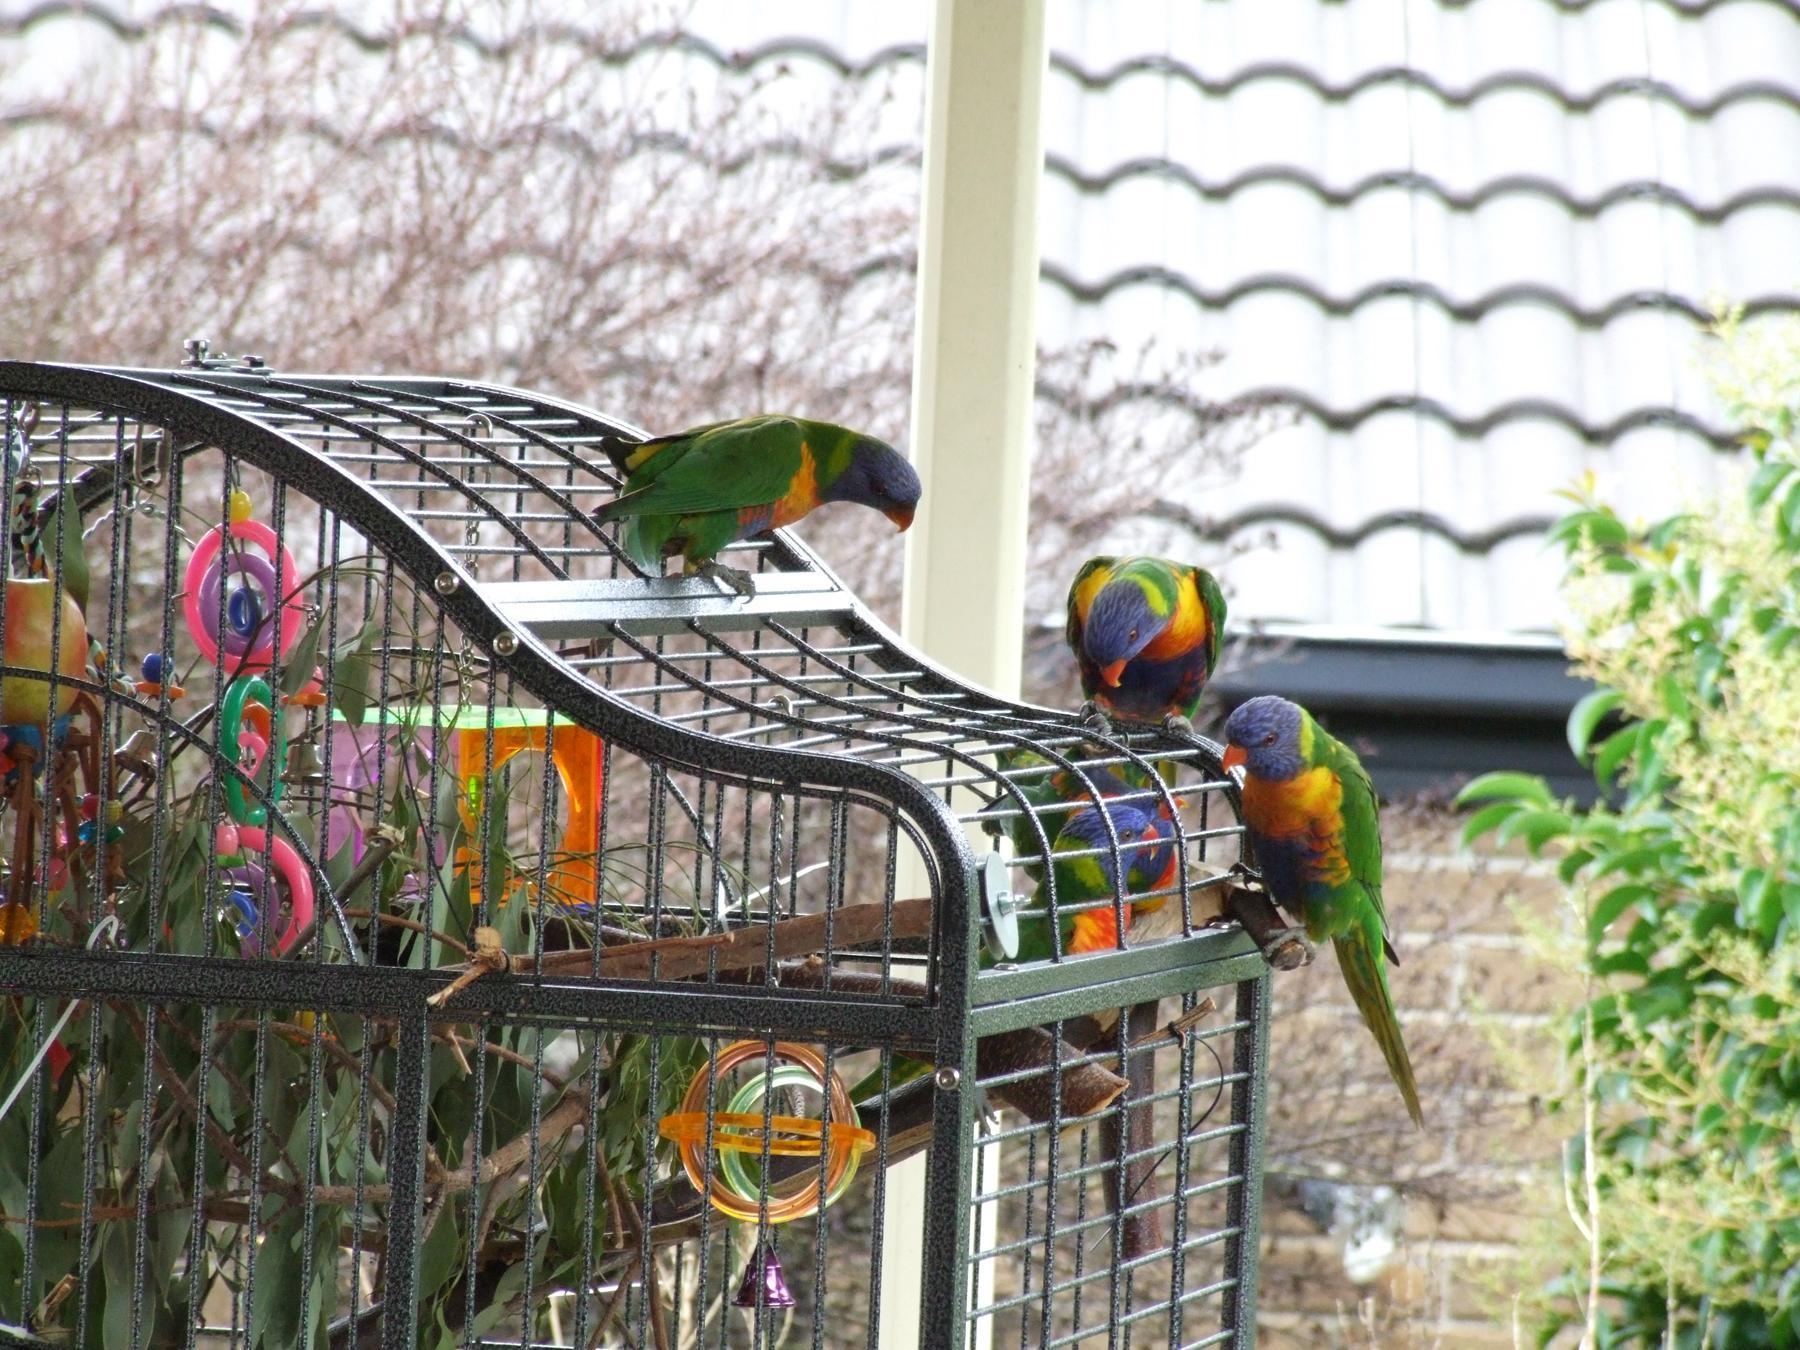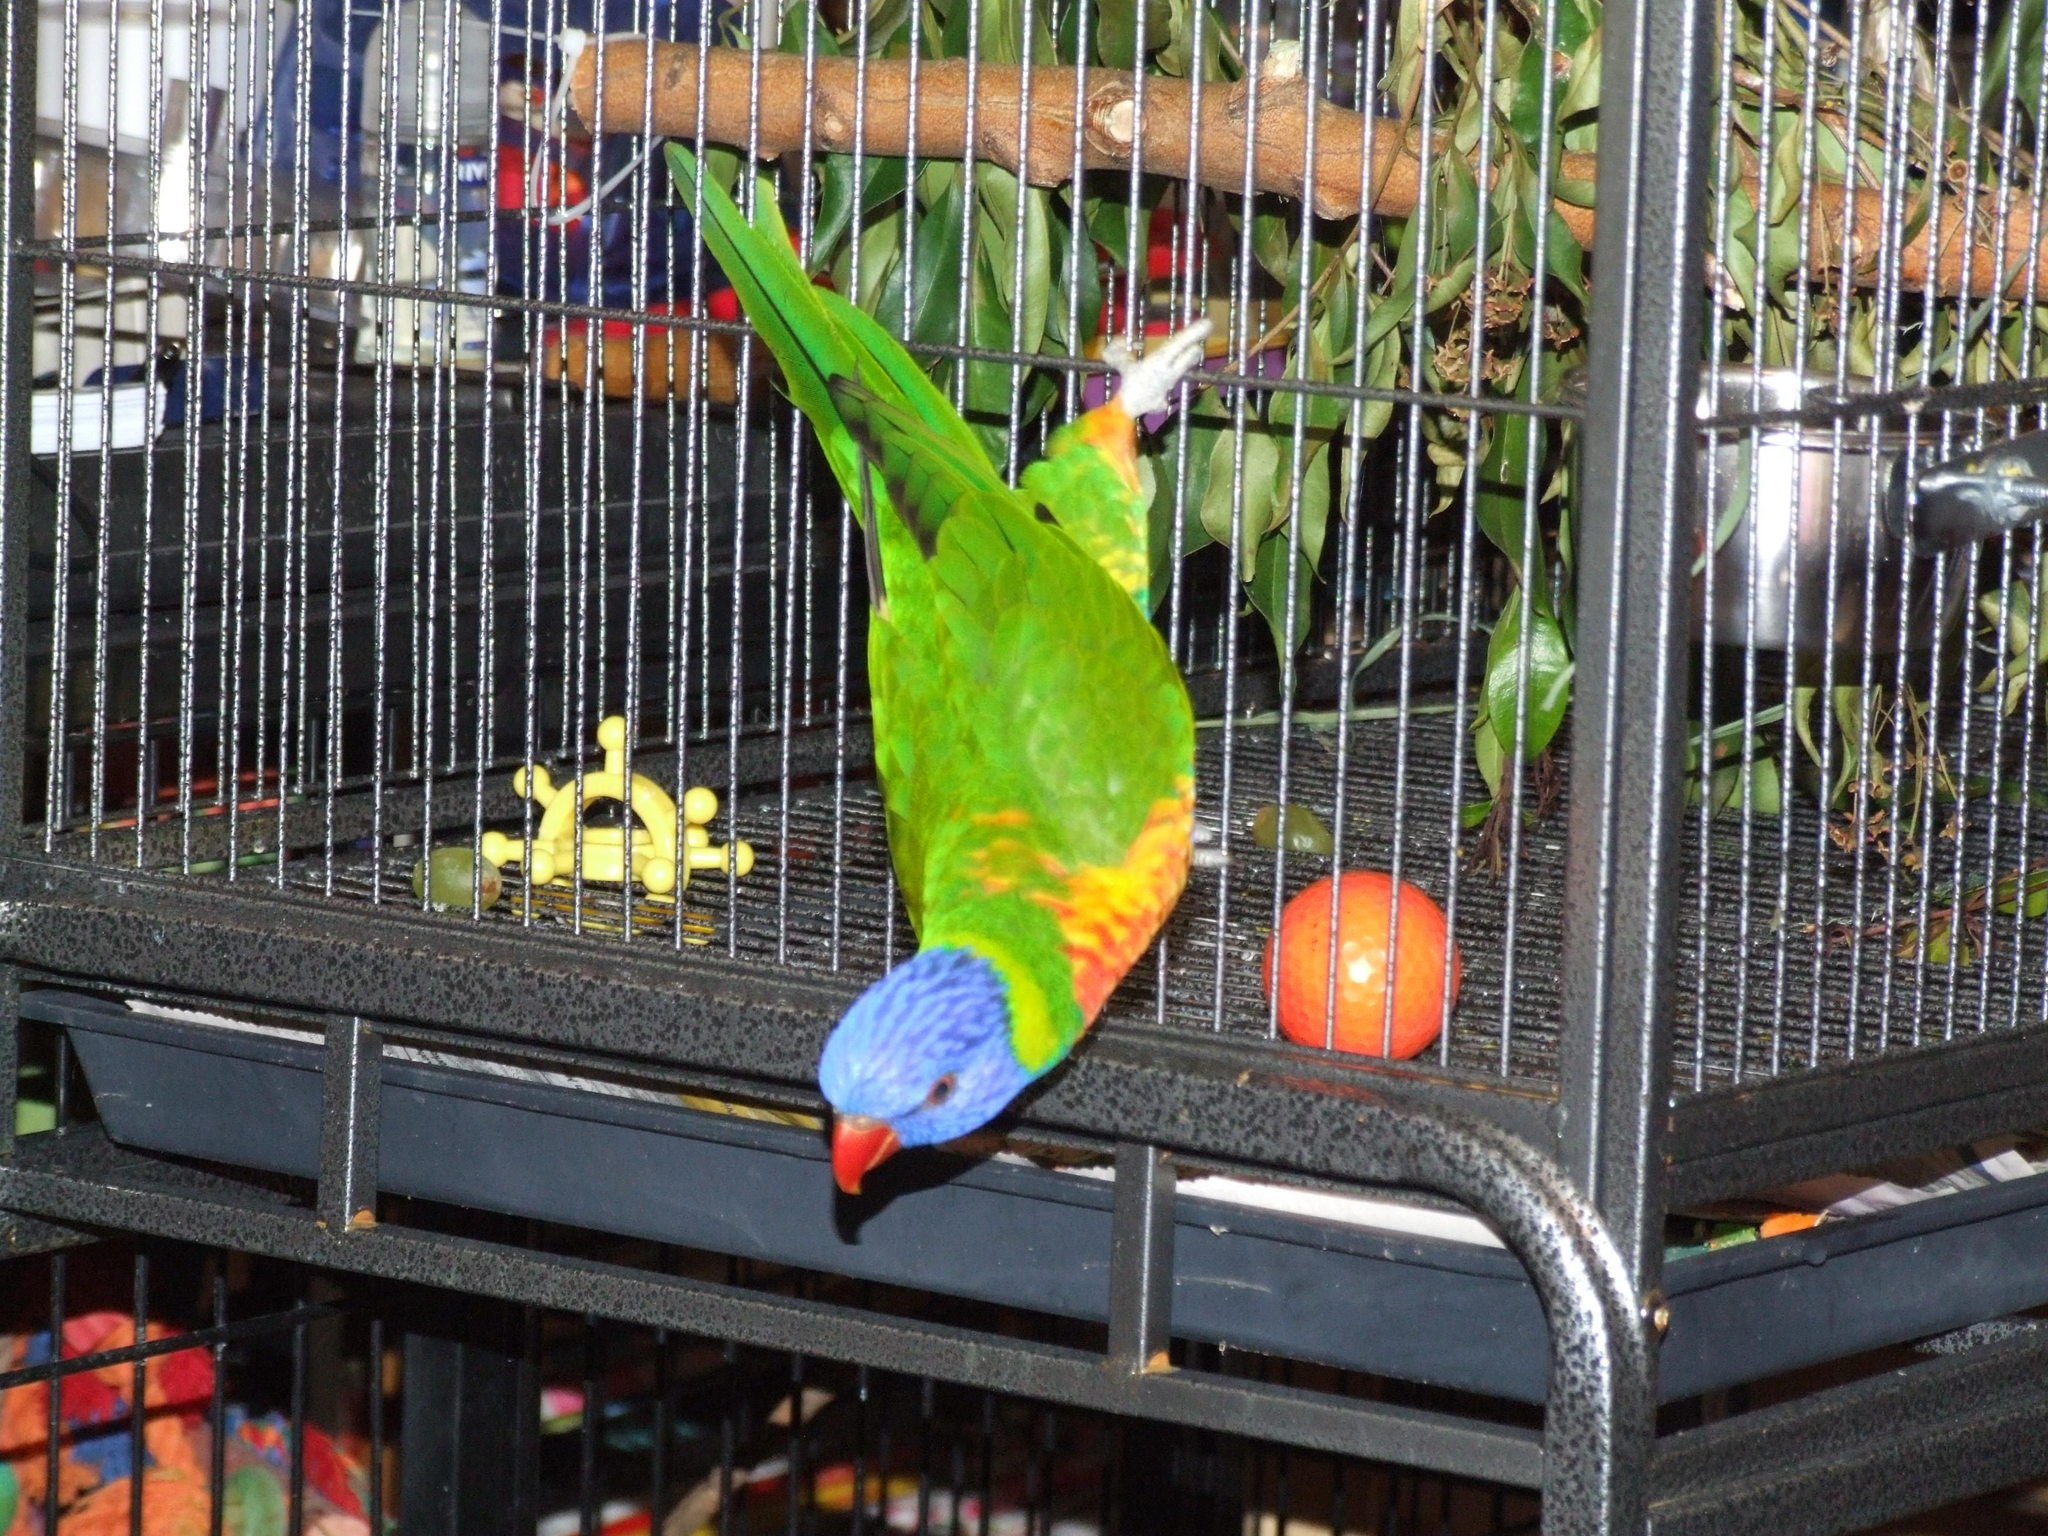The first image is the image on the left, the second image is the image on the right. Evaluate the accuracy of this statement regarding the images: "All of the birds have blue heads and orange/yellow bellies.". Is it true? Answer yes or no. Yes. The first image is the image on the left, the second image is the image on the right. Assess this claim about the two images: "Each image shows exactly two birds within a cage.". Correct or not? Answer yes or no. No. 